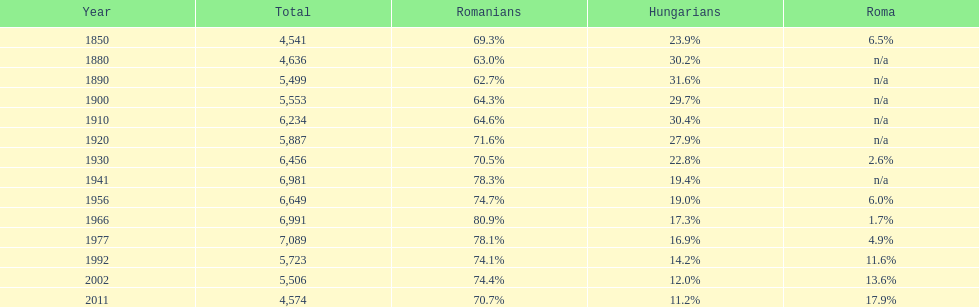In the most recent year displayed on this chart, what proportion of the population consisted of romanians? 70.7%. Could you parse the entire table as a dict? {'header': ['Year', 'Total', 'Romanians', 'Hungarians', 'Roma'], 'rows': [['1850', '4,541', '69.3%', '23.9%', '6.5%'], ['1880', '4,636', '63.0%', '30.2%', 'n/a'], ['1890', '5,499', '62.7%', '31.6%', 'n/a'], ['1900', '5,553', '64.3%', '29.7%', 'n/a'], ['1910', '6,234', '64.6%', '30.4%', 'n/a'], ['1920', '5,887', '71.6%', '27.9%', 'n/a'], ['1930', '6,456', '70.5%', '22.8%', '2.6%'], ['1941', '6,981', '78.3%', '19.4%', 'n/a'], ['1956', '6,649', '74.7%', '19.0%', '6.0%'], ['1966', '6,991', '80.9%', '17.3%', '1.7%'], ['1977', '7,089', '78.1%', '16.9%', '4.9%'], ['1992', '5,723', '74.1%', '14.2%', '11.6%'], ['2002', '5,506', '74.4%', '12.0%', '13.6%'], ['2011', '4,574', '70.7%', '11.2%', '17.9%']]} 